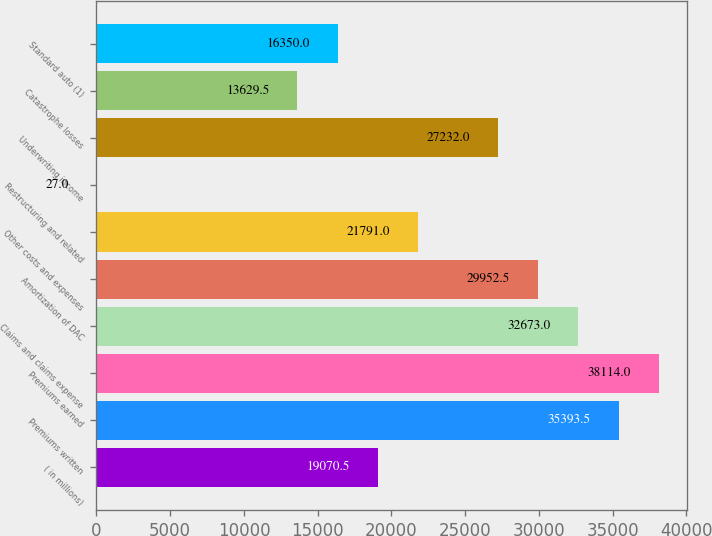Convert chart to OTSL. <chart><loc_0><loc_0><loc_500><loc_500><bar_chart><fcel>( in millions)<fcel>Premiums written<fcel>Premiums earned<fcel>Claims and claims expense<fcel>Amortization of DAC<fcel>Other costs and expenses<fcel>Restructuring and related<fcel>Underwriting income<fcel>Catastrophe losses<fcel>Standard auto (1)<nl><fcel>19070.5<fcel>35393.5<fcel>38114<fcel>32673<fcel>29952.5<fcel>21791<fcel>27<fcel>27232<fcel>13629.5<fcel>16350<nl></chart> 